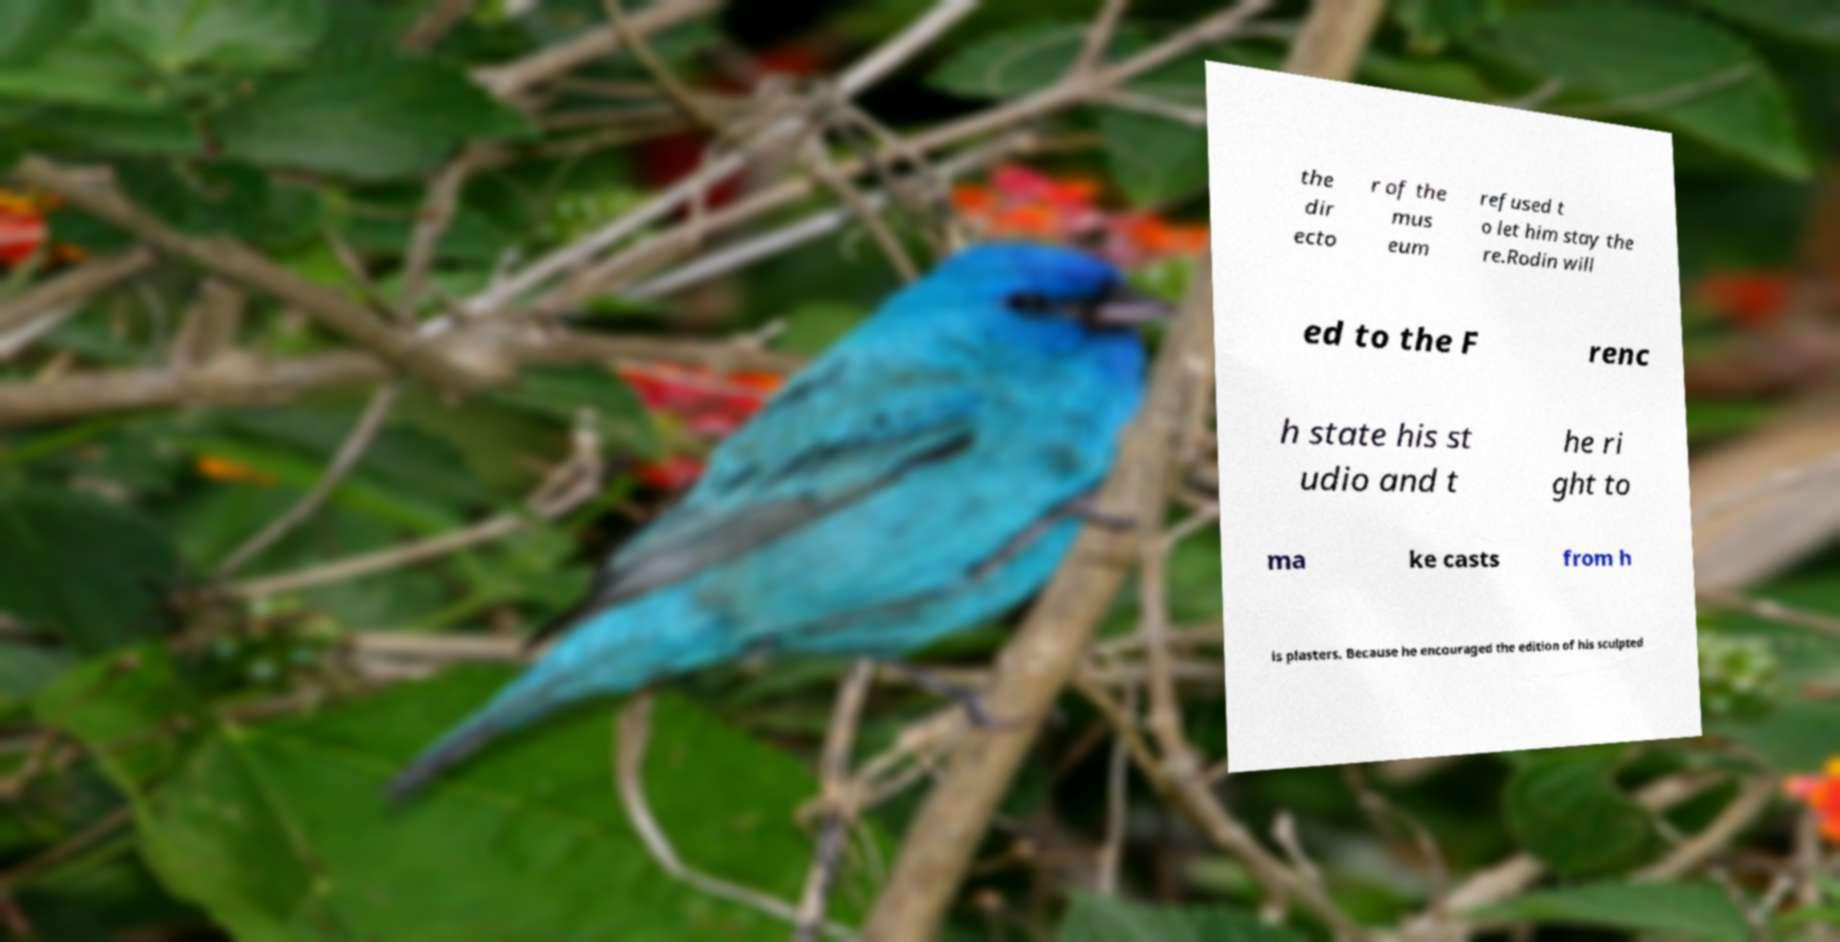Can you accurately transcribe the text from the provided image for me? the dir ecto r of the mus eum refused t o let him stay the re.Rodin will ed to the F renc h state his st udio and t he ri ght to ma ke casts from h is plasters. Because he encouraged the edition of his sculpted 